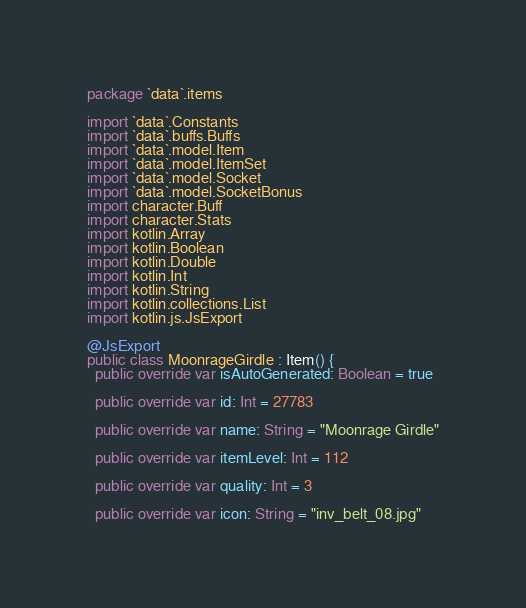Convert code to text. <code><loc_0><loc_0><loc_500><loc_500><_Kotlin_>package `data`.items

import `data`.Constants
import `data`.buffs.Buffs
import `data`.model.Item
import `data`.model.ItemSet
import `data`.model.Socket
import `data`.model.SocketBonus
import character.Buff
import character.Stats
import kotlin.Array
import kotlin.Boolean
import kotlin.Double
import kotlin.Int
import kotlin.String
import kotlin.collections.List
import kotlin.js.JsExport

@JsExport
public class MoonrageGirdle : Item() {
  public override var isAutoGenerated: Boolean = true

  public override var id: Int = 27783

  public override var name: String = "Moonrage Girdle"

  public override var itemLevel: Int = 112

  public override var quality: Int = 3

  public override var icon: String = "inv_belt_08.jpg"
</code> 